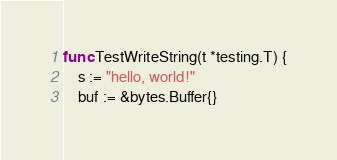Convert code to text. <code><loc_0><loc_0><loc_500><loc_500><_Go_>func TestWriteString(t *testing.T) {
	s := "hello, world!"
	buf := &bytes.Buffer{}
</code> 